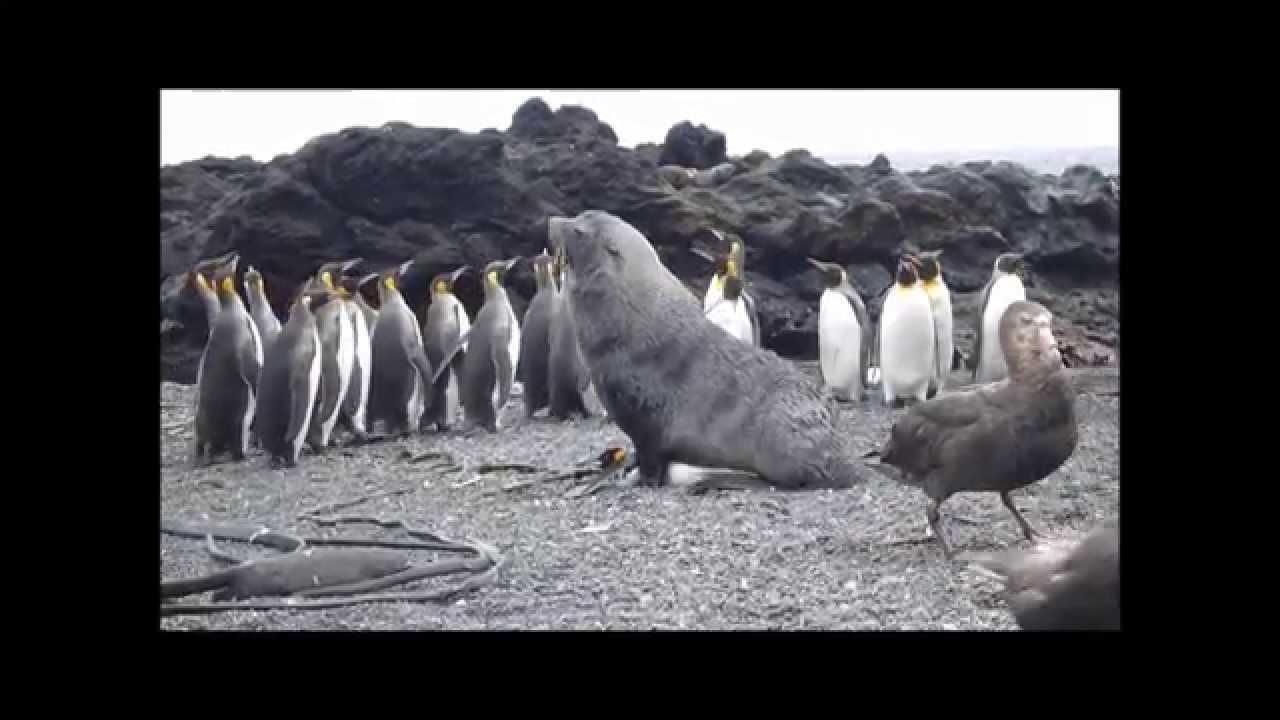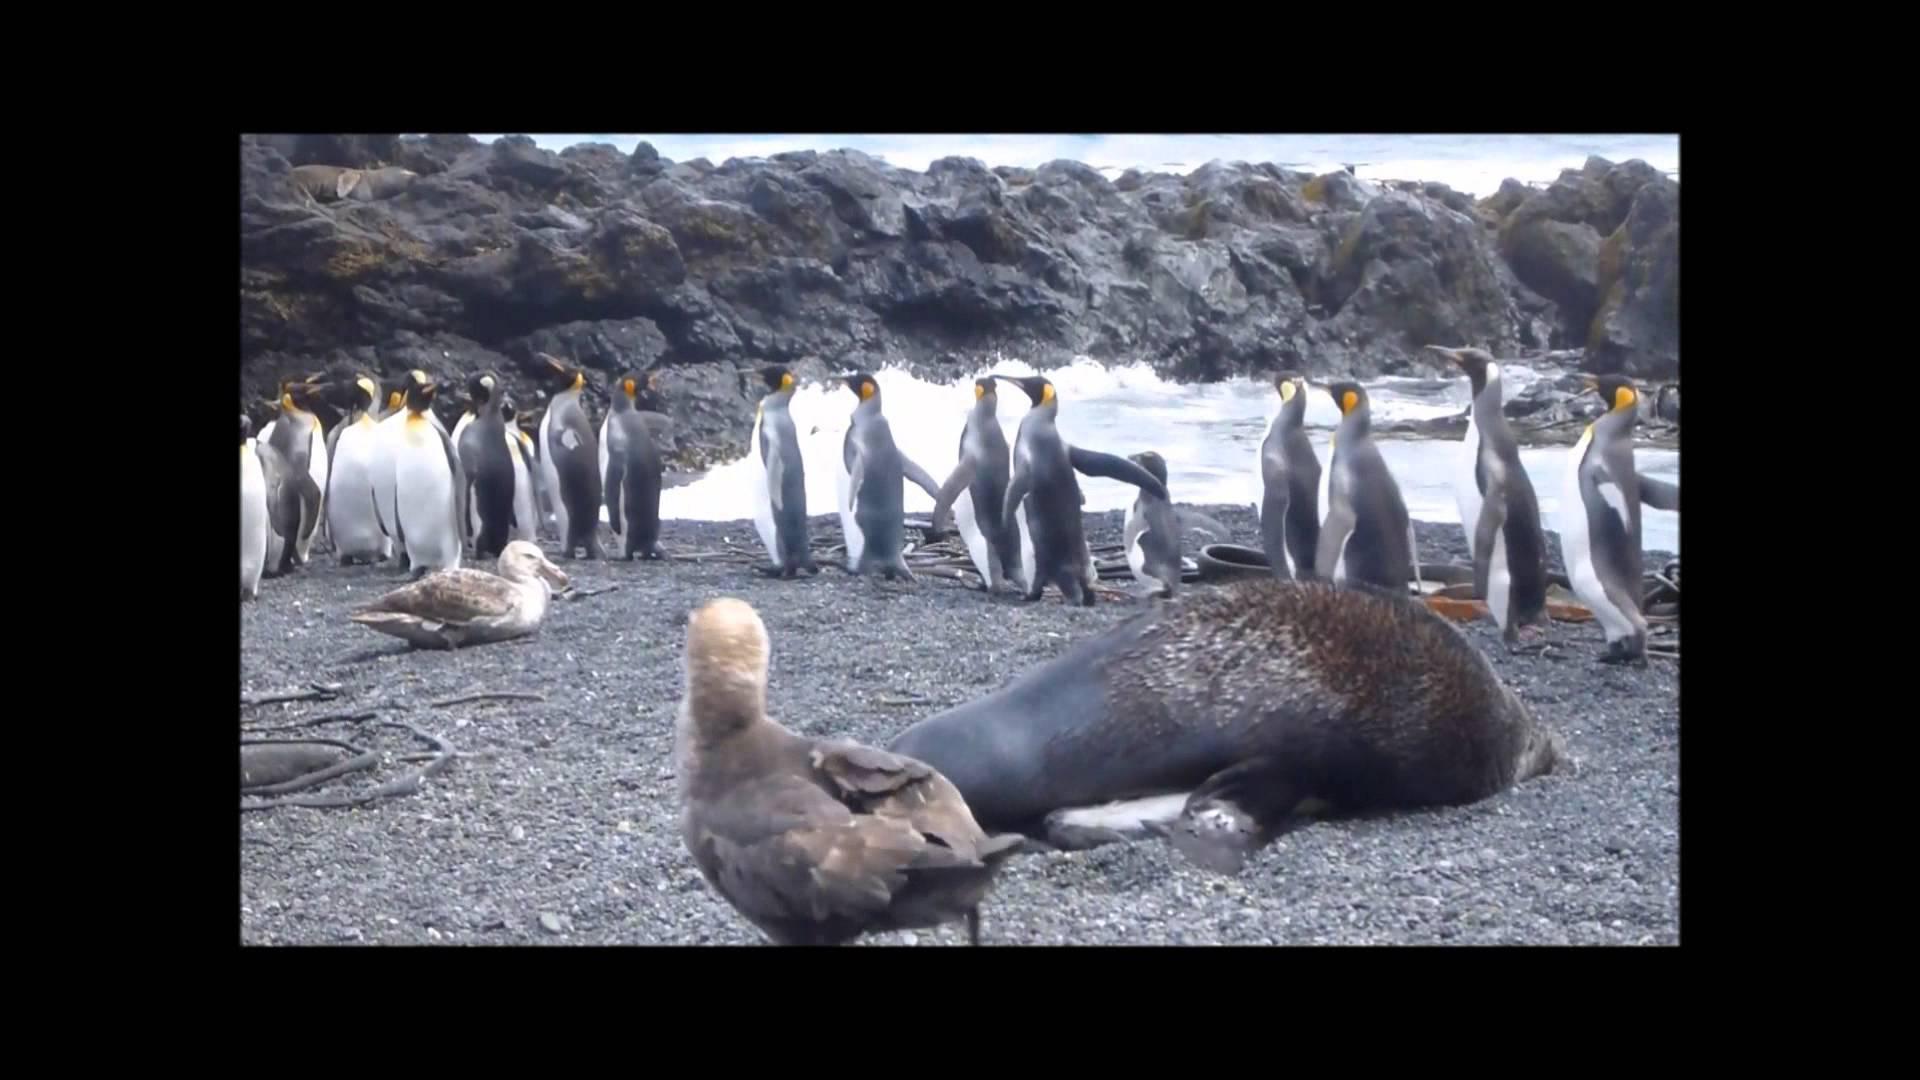The first image is the image on the left, the second image is the image on the right. Considering the images on both sides, is "There is a group of penguins standing near the water's edge with no bird in the forefront." valid? Answer yes or no. No. The first image is the image on the left, the second image is the image on the right. Given the left and right images, does the statement "In this image only land and sky are visible along side at least 8 penguins and a single sea lion." hold true? Answer yes or no. Yes. 